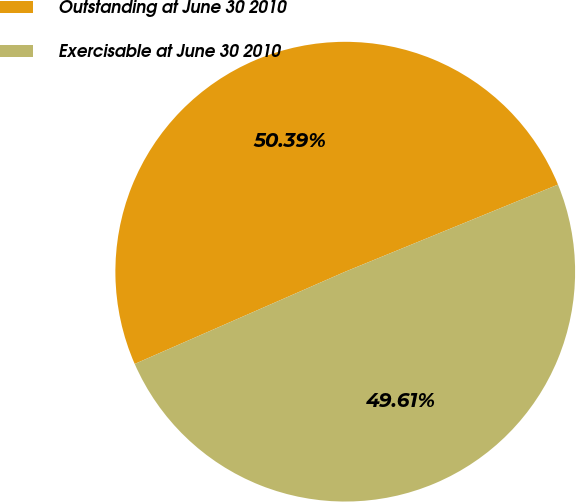<chart> <loc_0><loc_0><loc_500><loc_500><pie_chart><fcel>Outstanding at June 30 2010<fcel>Exercisable at June 30 2010<nl><fcel>50.39%<fcel>49.61%<nl></chart> 